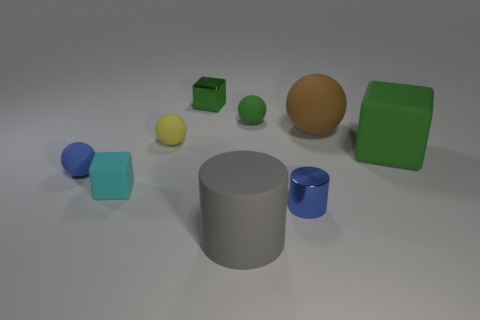Is the number of small cylinders that are left of the cyan matte cube the same as the number of rubber cylinders behind the big brown matte sphere?
Provide a succinct answer. Yes. There is a brown matte ball that is right of the blue metal cylinder; is its size the same as the green object that is in front of the large brown object?
Make the answer very short. Yes. What is the shape of the blue metal thing that is in front of the green thing on the right side of the tiny green thing that is in front of the small green metal object?
Your response must be concise. Cylinder. Is there anything else that has the same material as the blue ball?
Your answer should be very brief. Yes. What is the size of the green shiny object that is the same shape as the cyan rubber thing?
Your answer should be compact. Small. There is a tiny object that is to the right of the big gray object and behind the tiny blue metal thing; what is its color?
Provide a short and direct response. Green. Are the cyan block and the big thing that is on the right side of the brown rubber thing made of the same material?
Ensure brevity in your answer.  Yes. Is the number of green rubber objects in front of the tiny cyan cube less than the number of large green matte blocks?
Give a very brief answer. Yes. How many other objects are the same shape as the big gray thing?
Make the answer very short. 1. Is there anything else that has the same color as the small cylinder?
Your answer should be very brief. Yes. 